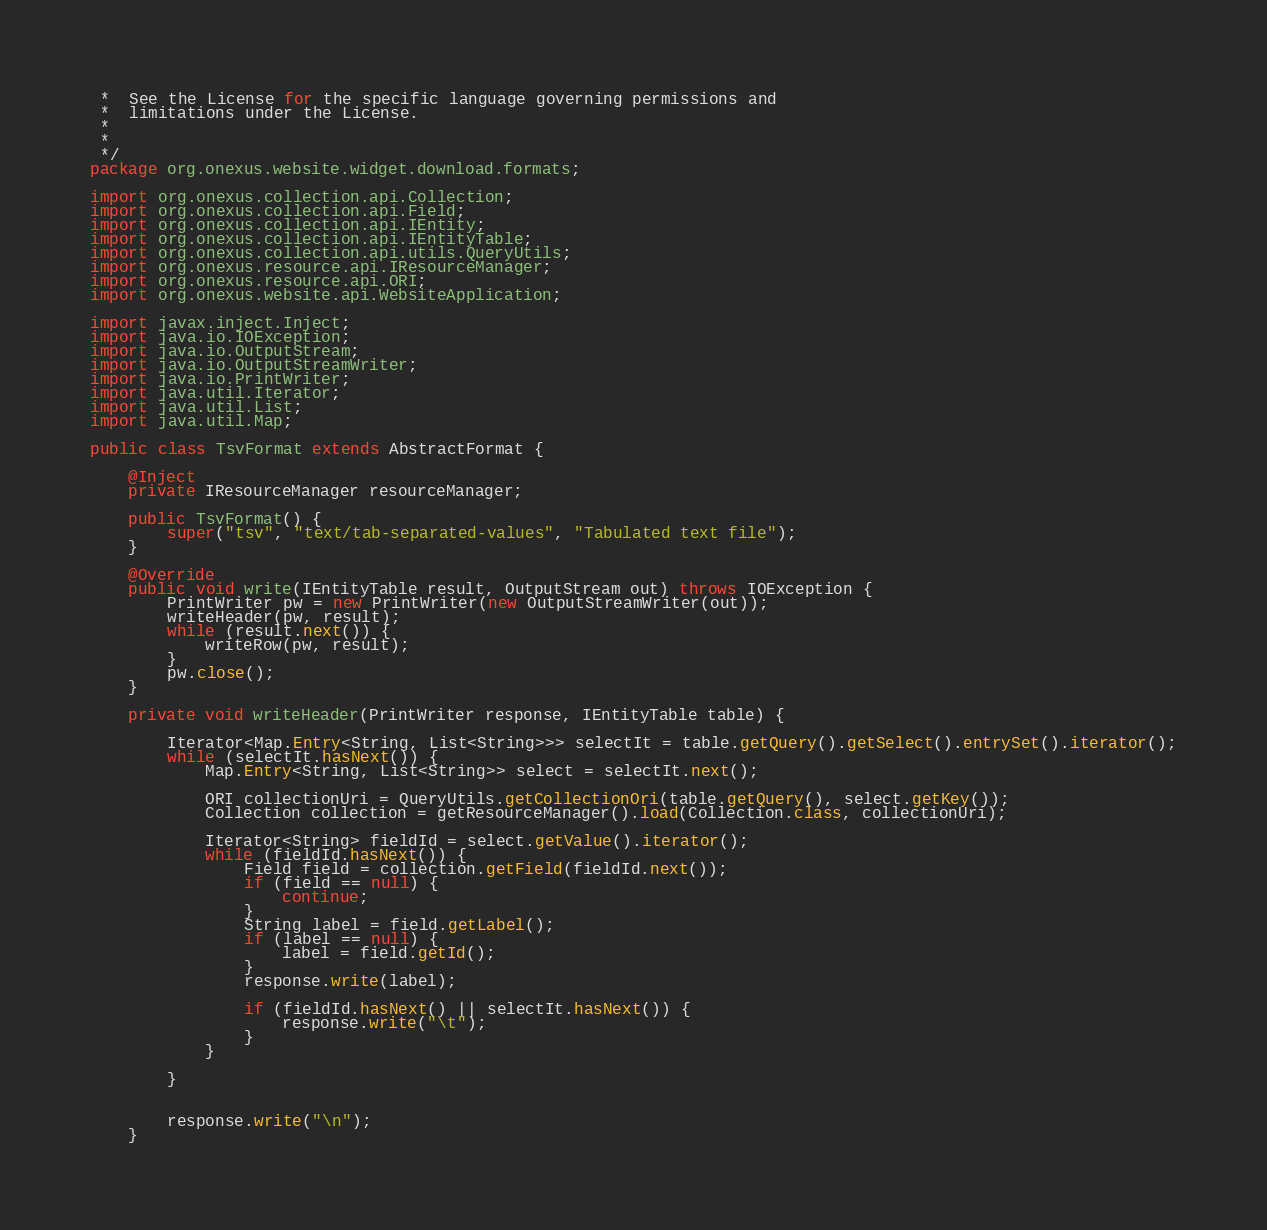<code> <loc_0><loc_0><loc_500><loc_500><_Java_> *  See the License for the specific language governing permissions and
 *  limitations under the License.
 *
 *
 */
package org.onexus.website.widget.download.formats;

import org.onexus.collection.api.Collection;
import org.onexus.collection.api.Field;
import org.onexus.collection.api.IEntity;
import org.onexus.collection.api.IEntityTable;
import org.onexus.collection.api.utils.QueryUtils;
import org.onexus.resource.api.IResourceManager;
import org.onexus.resource.api.ORI;
import org.onexus.website.api.WebsiteApplication;

import javax.inject.Inject;
import java.io.IOException;
import java.io.OutputStream;
import java.io.OutputStreamWriter;
import java.io.PrintWriter;
import java.util.Iterator;
import java.util.List;
import java.util.Map;

public class TsvFormat extends AbstractFormat {

    @Inject
    private IResourceManager resourceManager;

    public TsvFormat() {
        super("tsv", "text/tab-separated-values", "Tabulated text file");
    }

    @Override
    public void write(IEntityTable result, OutputStream out) throws IOException {
        PrintWriter pw = new PrintWriter(new OutputStreamWriter(out));
        writeHeader(pw, result);
        while (result.next()) {
            writeRow(pw, result);
        }
        pw.close();
    }

    private void writeHeader(PrintWriter response, IEntityTable table) {

        Iterator<Map.Entry<String, List<String>>> selectIt = table.getQuery().getSelect().entrySet().iterator();
        while (selectIt.hasNext()) {
            Map.Entry<String, List<String>> select = selectIt.next();

            ORI collectionUri = QueryUtils.getCollectionOri(table.getQuery(), select.getKey());
            Collection collection = getResourceManager().load(Collection.class, collectionUri);

            Iterator<String> fieldId = select.getValue().iterator();
            while (fieldId.hasNext()) {
                Field field = collection.getField(fieldId.next());
                if (field == null) {
                    continue;
                }
                String label = field.getLabel();
                if (label == null) {
                    label = field.getId();
                }
                response.write(label);

                if (fieldId.hasNext() || selectIt.hasNext()) {
                    response.write("\t");
                }
            }

        }


        response.write("\n");
    }
</code> 